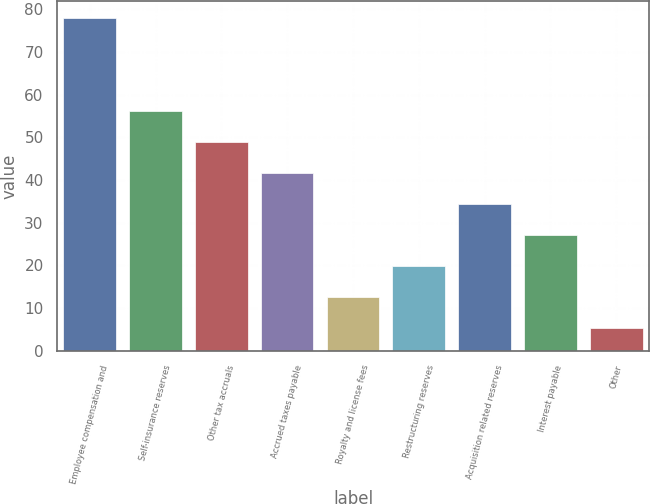<chart> <loc_0><loc_0><loc_500><loc_500><bar_chart><fcel>Employee compensation and<fcel>Self-insurance reserves<fcel>Other tax accruals<fcel>Accrued taxes payable<fcel>Royalty and license fees<fcel>Restructuring reserves<fcel>Acquisition related reserves<fcel>Interest payable<fcel>Other<nl><fcel>78<fcel>56.22<fcel>48.96<fcel>41.7<fcel>12.66<fcel>19.92<fcel>34.44<fcel>27.18<fcel>5.4<nl></chart> 